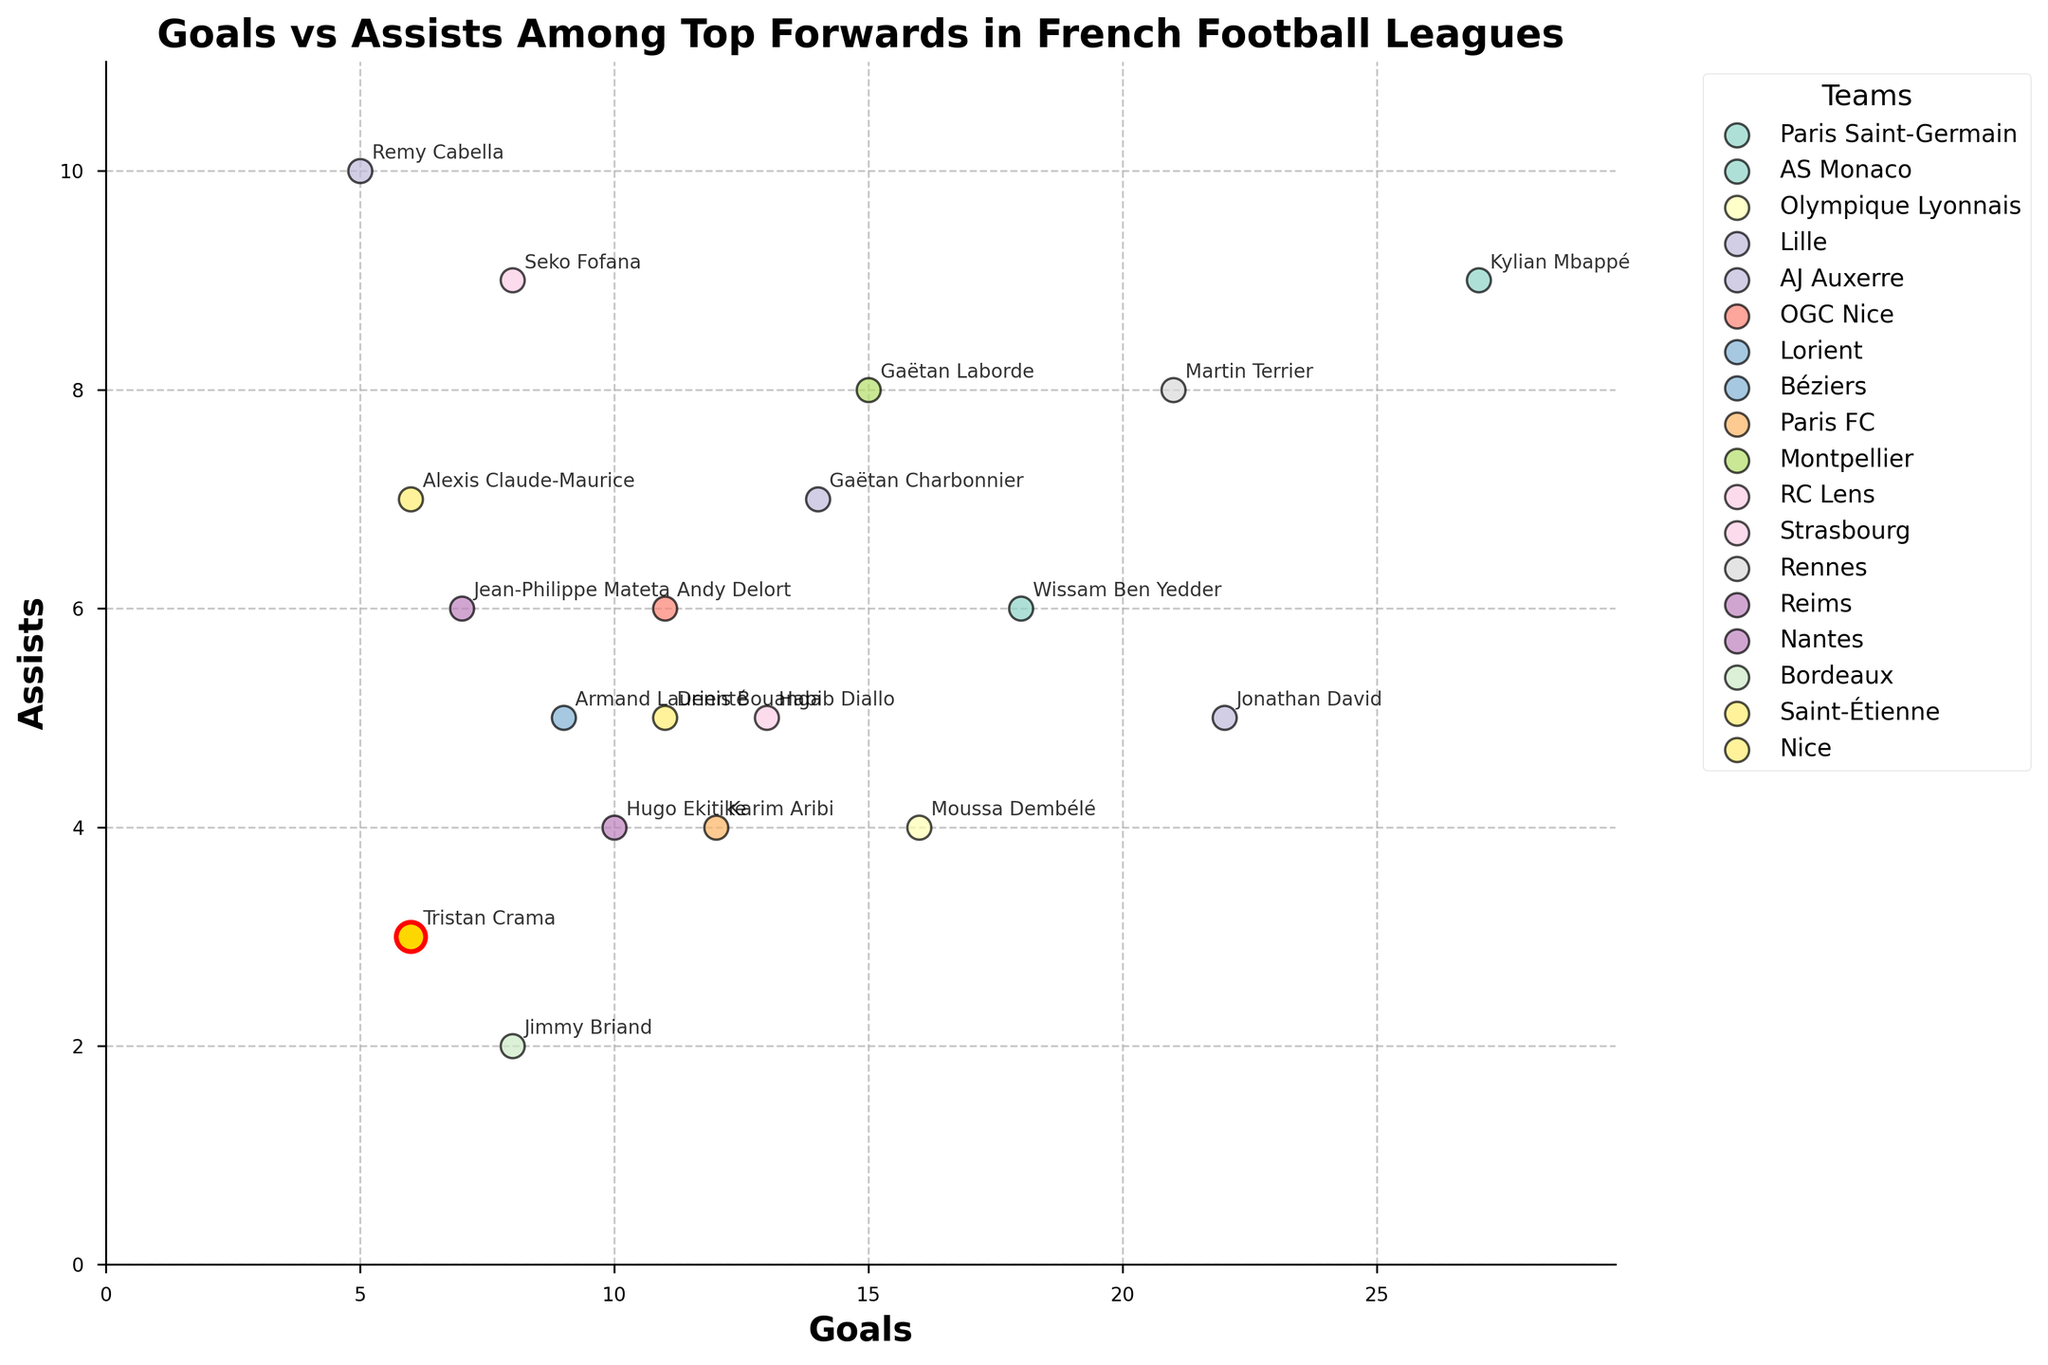How many goals did Tristan Crama score? Look for Tristan Crama on the scatter plot and check the value on the x-axis corresponding to his point.
Answer: 6 Which team has the player with the highest number of assists? Find the point that is positioned the highest on the y-axis, and check the team associated with this player.
Answer: Lille Compare Tristan Crama to Remy Cabella in terms of assists. Who has more, and by how much? Identify Tristan Crama and Remy Cabella on the scatter plot, then find their positions on the y-axis. Calculate the difference between their assist values. Tristan Crama has 3 assists, and Remy Cabella has 10. 10 - 3 = 7. Remy Cabella has 7 more assists than Tristan Crama.
Answer: Remy Cabella, 7 Which player from Béziers is highlighted, and with what color? Identify the player from Béziers, highlighted in a distinct color, typically emphasized on the plot.
Answer: Tristan Crama, gold What is the overall trend between goals and assists among the top forwards? Observe the scatter plot and determine if there is a visible pattern. Most points should either show a correlation (upward trend) or no clear trend between goals and assists.
Answer: No clear trend Who has the highest combined total of goals and assists? For each player, add up their goals and assists, then identify the player with the highest sum. Kylian Mbappé has 27 goals and 9 assists (27 + 9 = 36), which is the highest.
Answer: Kylian Mbappé How many players have scored more goals than Tristan Crama? Count the number of points on the scatter plot that are positioned to the right of Tristan Crama's point on the x-axis.
Answer: 13 What is the average number of goals scored by players from Paris Saint-Germain and OGC Nice? Sum the goals of Paris Saint-Germain (27) and OGC Nice (11), then divide by the number of players (2). (27 + 11) / 2 = 19.
Answer: 19 Which player from AS Monaco has more assists, and by how many? Identify the player(s) from AS Monaco and compare their positions on the y-axis. Wissam Ben Yedder has 6 assists. He is the only player from AS Monaco in the data.
Answer: Wissam Ben Yedder, 6 